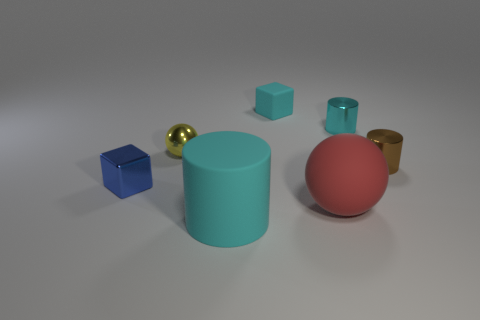Add 2 matte objects. How many objects exist? 9 Subtract all cubes. How many objects are left? 5 Add 4 large red matte balls. How many large red matte balls exist? 5 Subtract 0 purple spheres. How many objects are left? 7 Subtract all cylinders. Subtract all metal things. How many objects are left? 0 Add 4 small metallic balls. How many small metallic balls are left? 5 